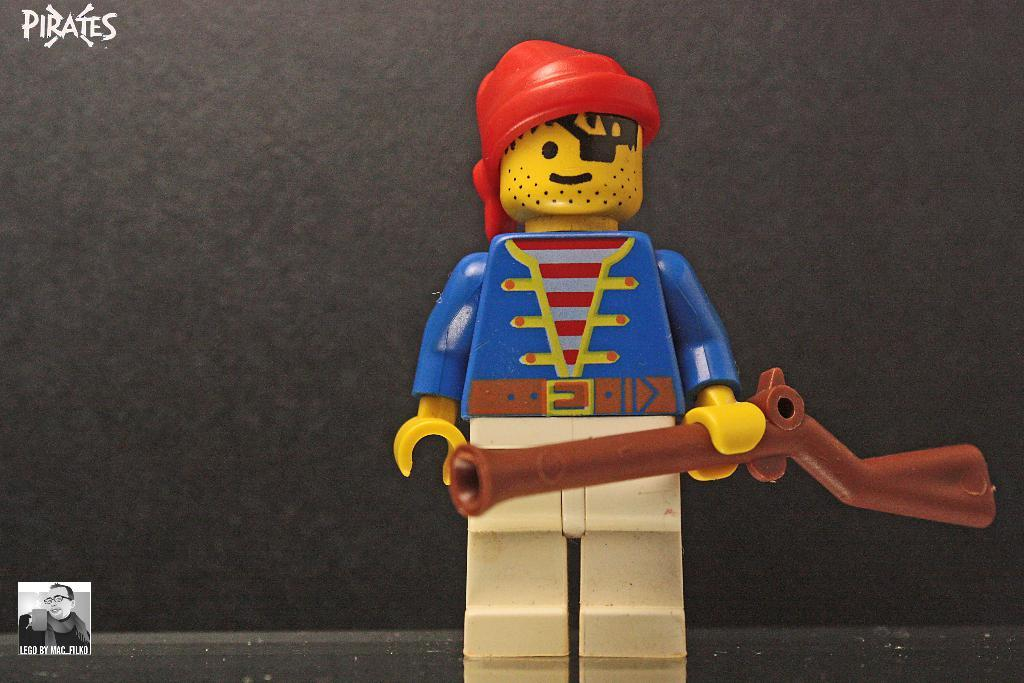What type of toy is present in the image? There is a plastic puppet in the image. What other object can be seen in the image? There is a gun in the image. What color is the background of the image? The background of the image is black. How many dogs are visible in the image? There are no dogs present in the image. What type of joke is being told by the plastic puppet in the image? The plastic puppet is not telling a joke in the image, as it is an inanimate object. 